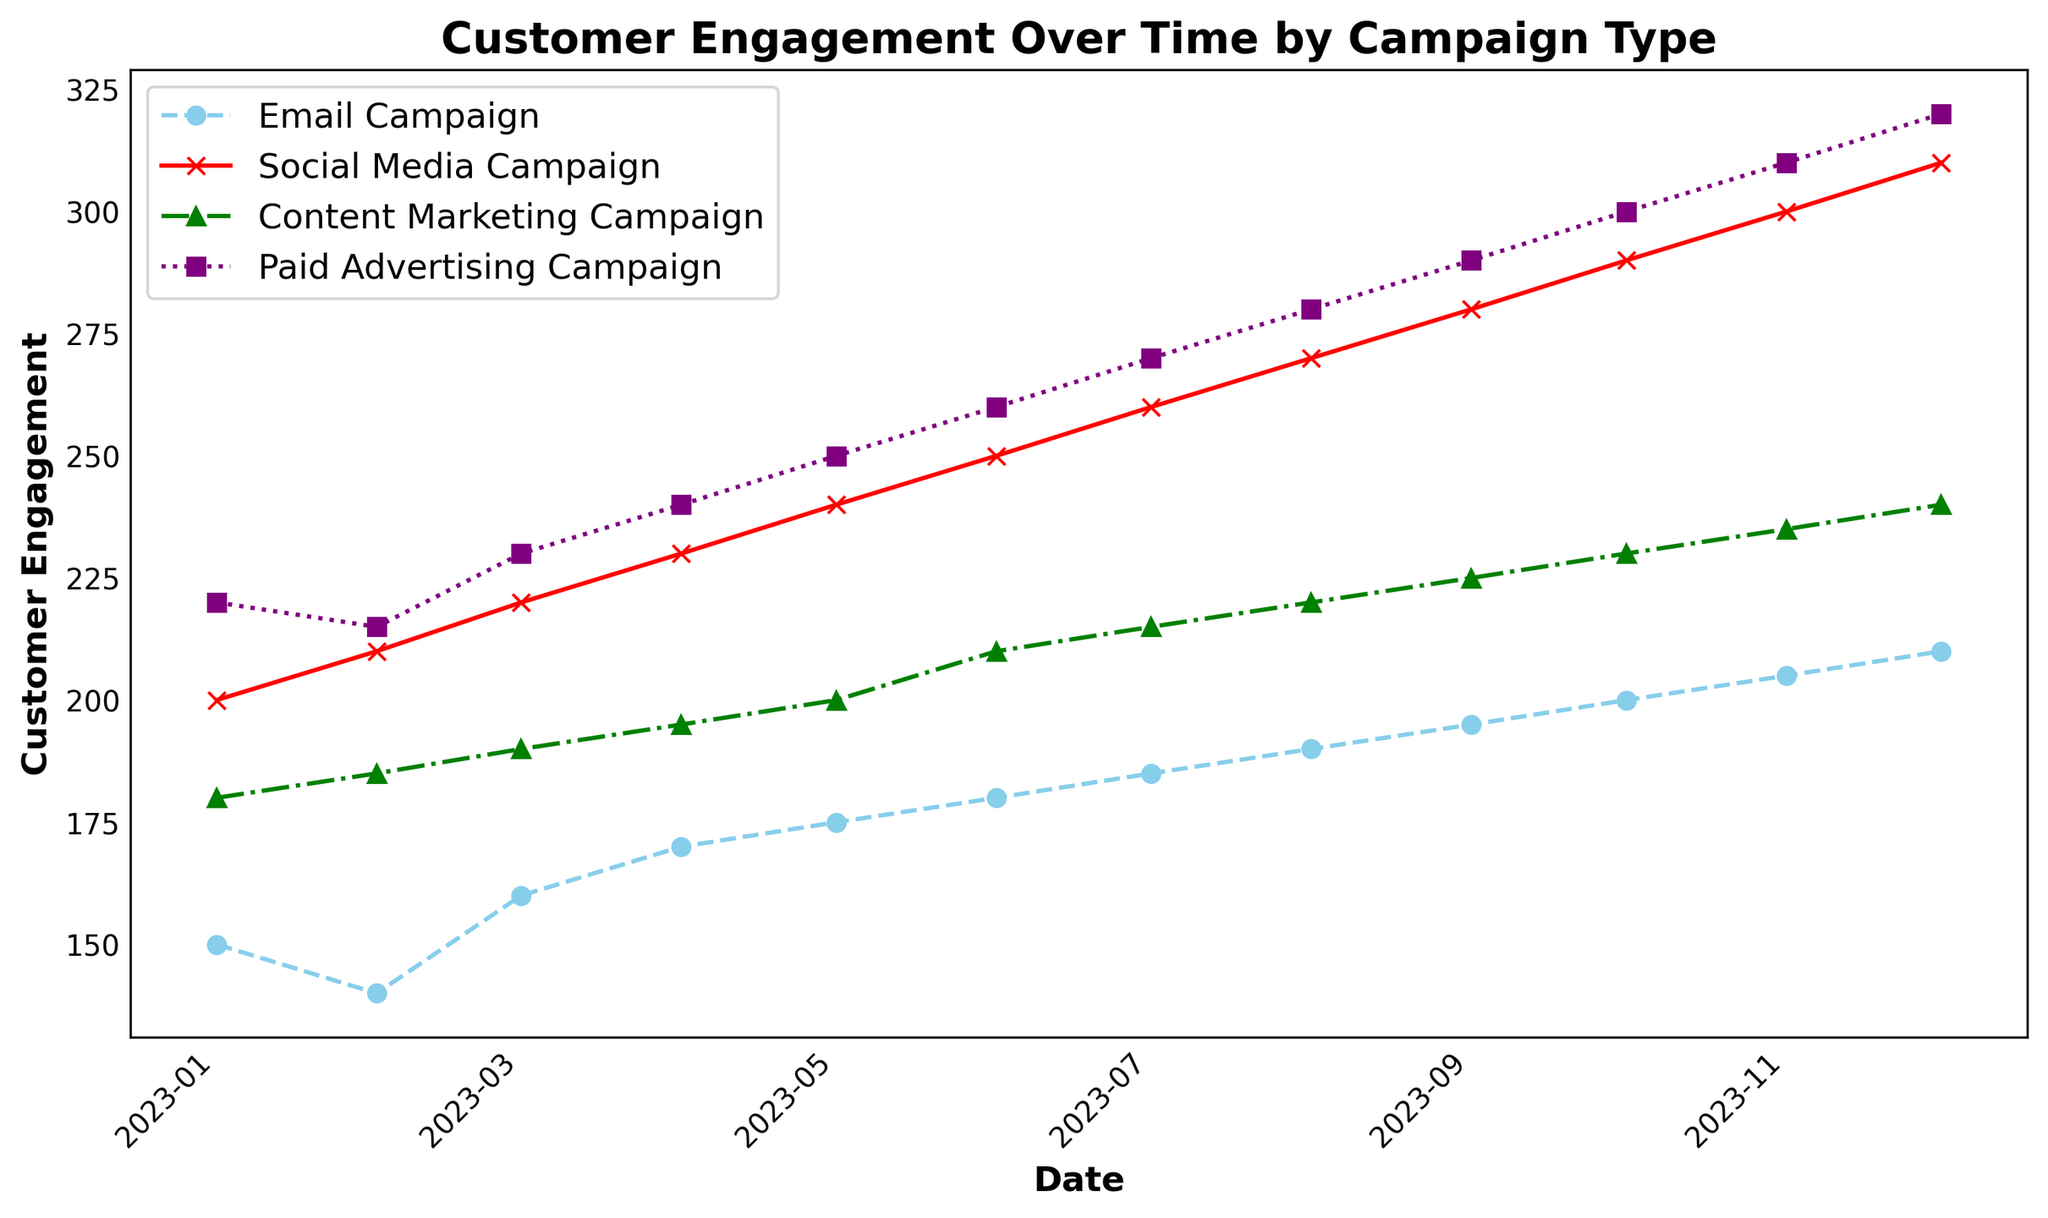When was the highest customer engagement seen for the Paid Advertising Campaign? Look for the line representing the Paid Advertising Campaign (purple color with square markers). Identify the highest point on this line, which occurs in December 2023.
Answer: December 2023 How much did customer engagement in the Social Media Campaign increase from January 2023 to December 2023? Find the data points for the Social Media Campaign (red color with x markers) at January 2023 (200) and December 2023 (310). Subtract the January value from the December value: 310 - 200 = 110.
Answer: 110 Which campaign observed the least growth in customer engagement from January 2023 to December 2023? Calculate the growth for each campaign by subtracting the January value from the December value:
- Email Campaign: 210 - 150 = 60
- Social Media Campaign: 310 - 200 = 110
- Content Marketing Campaign: 240 - 180 = 60
- Paid Advertising Campaign: 320 - 220 = 100
Both the Email Campaign and Content Marketing Campaign had the least growth of 60.
Answer: Email Campaign and Content Marketing Campaign Compare the rates of increase in customer engagement between the Social Media Campaign and the Content Marketing Campaign. Which one increased more rapidly? Calculate the monthly growth rate over the period from January to December (11 months):
- Social Media Campaign: (310 - 200) / 11 = 10
- Content Marketing Campaign: (240 - 180) / 11 = ~5.45
The Social Media Campaign increased more rapidly.
Answer: Social Media Campaign In which month did the Email Campaign surpass 170 in customer engagement? Look at the Email Campaign line (sky blue color with circle markers) and find the first month where customer engagement is greater than 170, which is April 2023.
Answer: April 2023 Between August 2023 and October 2023, how did customer engagement change in the Content Marketing Campaign? Find the data points for the Content Marketing Campaign (green color with triangle markers) at August 2023 (220) and October 2023 (230). Subtract the August value from the October value: 230 - 220 = 10.
Answer: Increased by 10 What is the total customer engagement across all campaigns in September 2023? Sum up the customer engagement values for all campaigns in September 2023: 
195 (Email) + 280 (Social Media) + 225 (Content Marketing) + 290 (Paid Advertising) = 990.
Answer: 990 